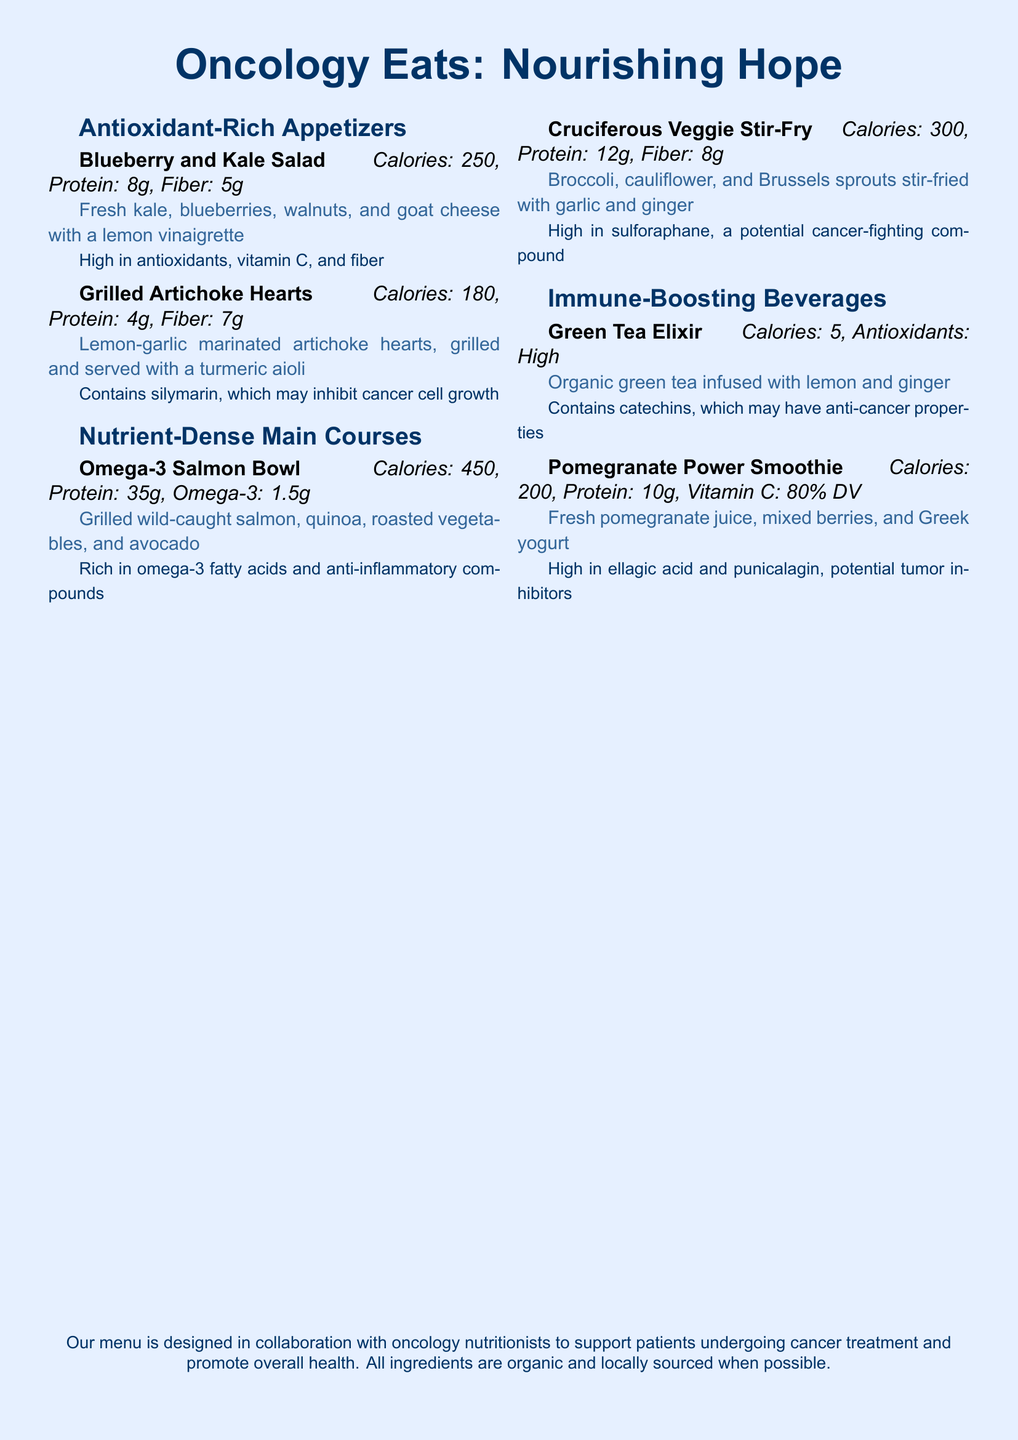What is the title of the menu? The title of the menu is prominently displayed at the top of the document.
Answer: Oncology Eats: Nourishing Hope Which appetizer contains silymarin? The document lists appetizers along with their health benefits. Silymarin is mentioned in relation to the Grilled Artichoke Hearts.
Answer: Grilled Artichoke Hearts What is the calorie count of the Omega-3 Salmon Bowl? The menu item details the calories for each dish, specifically listing it for the Omega-3 Salmon Bowl.
Answer: 450 How many grams of protein are in the Pomegranate Power Smoothie? The nutritional information for the Pomegranate Power Smoothie is provided in the document.
Answer: 10g What is the main vegetable in the Cruciferous Veggie Stir-Fry? The description for the Cruciferous Veggie Stir-Fry highlights its main ingredients.
Answer: Broccoli Which beverage is rich in catechins? The health benefits and ingredients for each beverage are listed, with catechins associated with the Green Tea Elixir.
Answer: Green Tea Elixir What is the fiber content of the Grilled Artichoke Hearts? The fiber content is provided for each menu item, specifically for the Grilled Artichoke Hearts.
Answer: 7g What ingredient in the Blueberry and Kale Salad provides vitamin C? The ingredients of the Blueberry and Kale Salad indicate that blueberries are a rich source of vitamin C.
Answer: Blueberries 